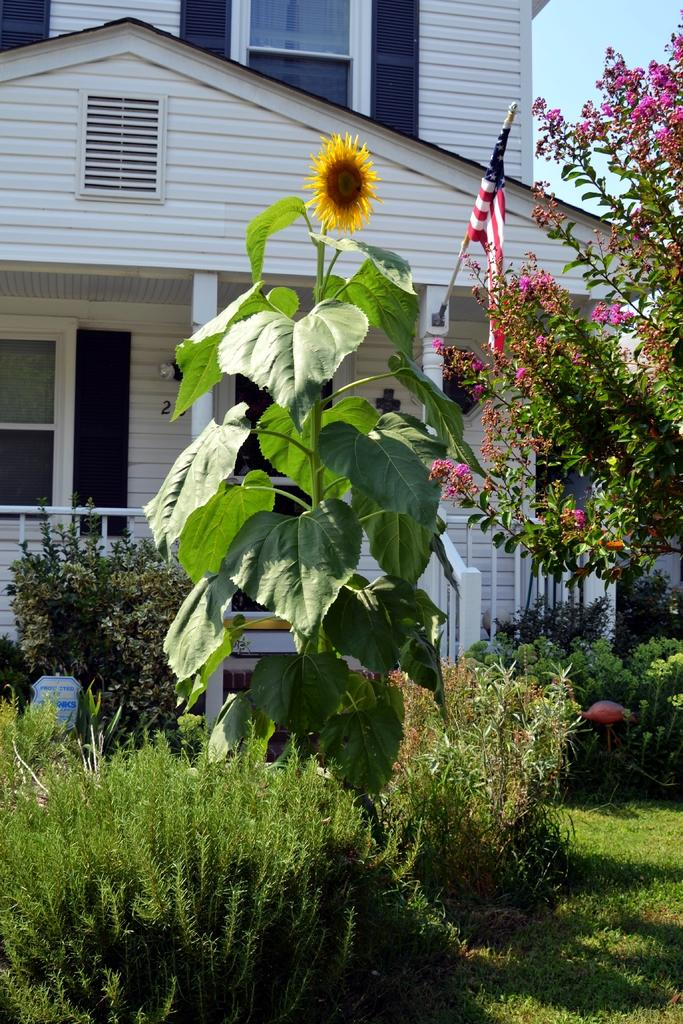What type of structure is visible in the image? There is a building in the image. What is flying near the building? There is a flag in the image. What type of natural elements can be seen in the image? There are trees and plants in the image. Can you identify a specific type of plant in the image? Yes, there is a sunflower in the image. What type of game is being played in the image? There is no game being played in the image. How many kittens can be seen playing in the image? There are no kittens present in the image. 